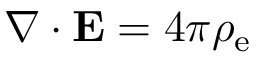Convert formula to latex. <formula><loc_0><loc_0><loc_500><loc_500>\nabla \cdot E = 4 \pi \rho _ { e }</formula> 